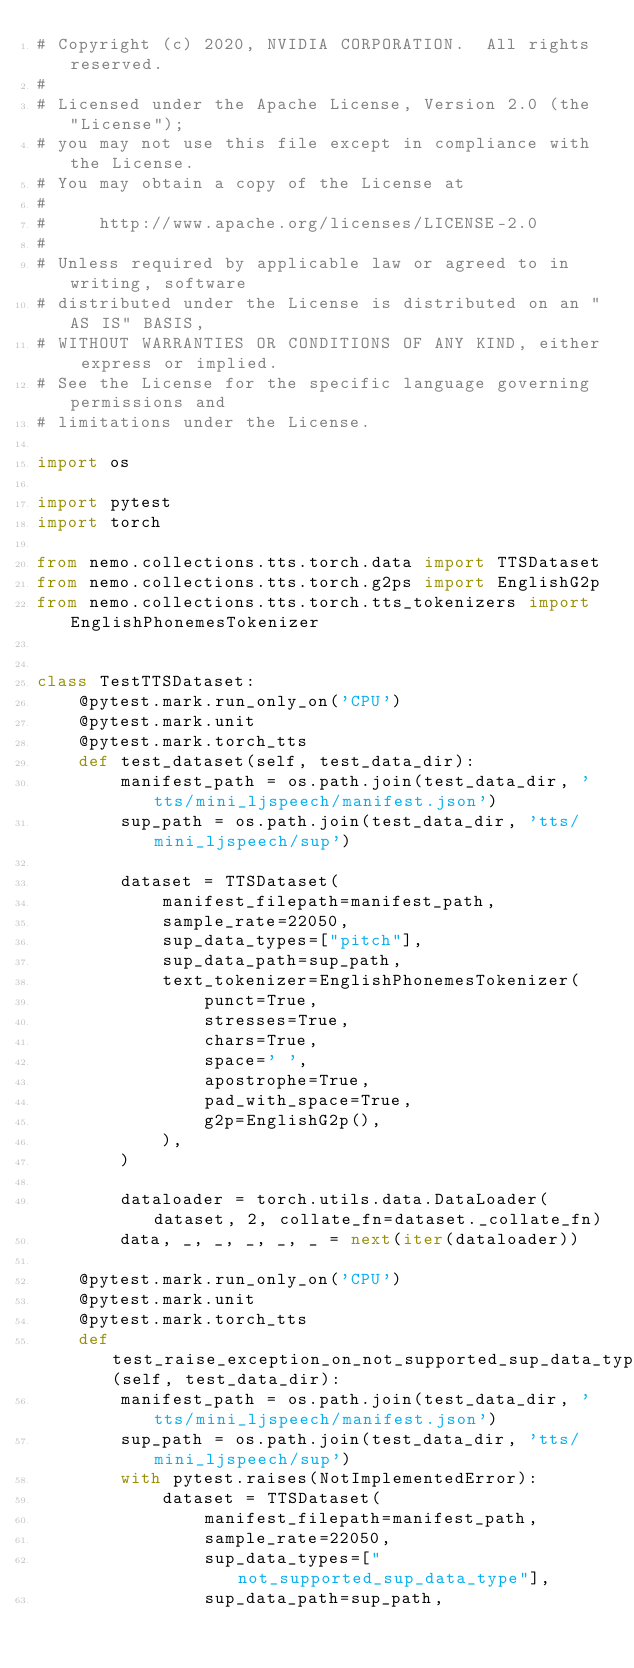<code> <loc_0><loc_0><loc_500><loc_500><_Python_># Copyright (c) 2020, NVIDIA CORPORATION.  All rights reserved.
#
# Licensed under the Apache License, Version 2.0 (the "License");
# you may not use this file except in compliance with the License.
# You may obtain a copy of the License at
#
#     http://www.apache.org/licenses/LICENSE-2.0
#
# Unless required by applicable law or agreed to in writing, software
# distributed under the License is distributed on an "AS IS" BASIS,
# WITHOUT WARRANTIES OR CONDITIONS OF ANY KIND, either express or implied.
# See the License for the specific language governing permissions and
# limitations under the License.

import os

import pytest
import torch

from nemo.collections.tts.torch.data import TTSDataset
from nemo.collections.tts.torch.g2ps import EnglishG2p
from nemo.collections.tts.torch.tts_tokenizers import EnglishPhonemesTokenizer


class TestTTSDataset:
    @pytest.mark.run_only_on('CPU')
    @pytest.mark.unit
    @pytest.mark.torch_tts
    def test_dataset(self, test_data_dir):
        manifest_path = os.path.join(test_data_dir, 'tts/mini_ljspeech/manifest.json')
        sup_path = os.path.join(test_data_dir, 'tts/mini_ljspeech/sup')

        dataset = TTSDataset(
            manifest_filepath=manifest_path,
            sample_rate=22050,
            sup_data_types=["pitch"],
            sup_data_path=sup_path,
            text_tokenizer=EnglishPhonemesTokenizer(
                punct=True,
                stresses=True,
                chars=True,
                space=' ',
                apostrophe=True,
                pad_with_space=True,
                g2p=EnglishG2p(),
            ),
        )

        dataloader = torch.utils.data.DataLoader(dataset, 2, collate_fn=dataset._collate_fn)
        data, _, _, _, _, _ = next(iter(dataloader))

    @pytest.mark.run_only_on('CPU')
    @pytest.mark.unit
    @pytest.mark.torch_tts
    def test_raise_exception_on_not_supported_sup_data_types(self, test_data_dir):
        manifest_path = os.path.join(test_data_dir, 'tts/mini_ljspeech/manifest.json')
        sup_path = os.path.join(test_data_dir, 'tts/mini_ljspeech/sup')
        with pytest.raises(NotImplementedError):
            dataset = TTSDataset(
                manifest_filepath=manifest_path,
                sample_rate=22050,
                sup_data_types=["not_supported_sup_data_type"],
                sup_data_path=sup_path,</code> 